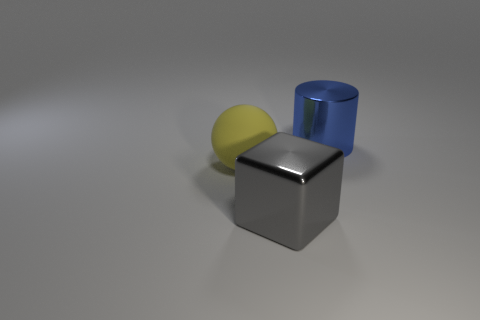Do the large thing behind the large ball and the gray metal object have the same shape? The large object behind the ball and the gray metal object do not share the same shape. The object behind the ball is a blue cylinder, while the gray object in the foreground is a cube. 